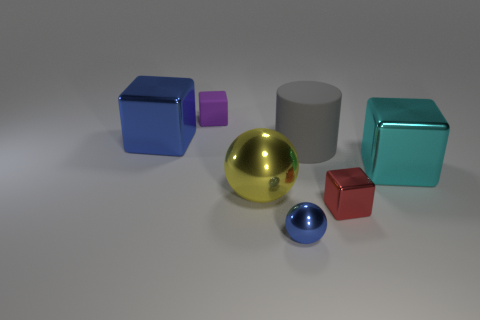Subtract all blue blocks. How many blocks are left? 3 Add 1 small metallic blocks. How many objects exist? 8 Subtract 2 blocks. How many blocks are left? 2 Subtract all red blocks. How many blocks are left? 3 Add 4 yellow things. How many yellow things exist? 5 Subtract 0 brown cubes. How many objects are left? 7 Subtract all spheres. How many objects are left? 5 Subtract all purple spheres. Subtract all yellow blocks. How many spheres are left? 2 Subtract all tiny red things. Subtract all big metal objects. How many objects are left? 3 Add 4 big cyan shiny objects. How many big cyan shiny objects are left? 5 